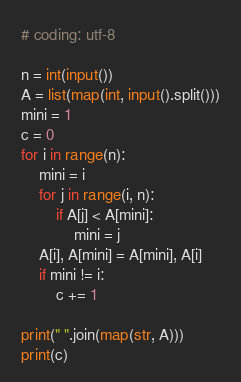Convert code to text. <code><loc_0><loc_0><loc_500><loc_500><_Python_># coding: utf-8

n = int(input())
A = list(map(int, input().split()))
mini = 1
c = 0
for i in range(n):
    mini = i
    for j in range(i, n):
        if A[j] < A[mini]:
            mini = j
    A[i], A[mini] = A[mini], A[i]
    if mini != i:
        c += 1

print(" ".join(map(str, A)))
print(c)</code> 